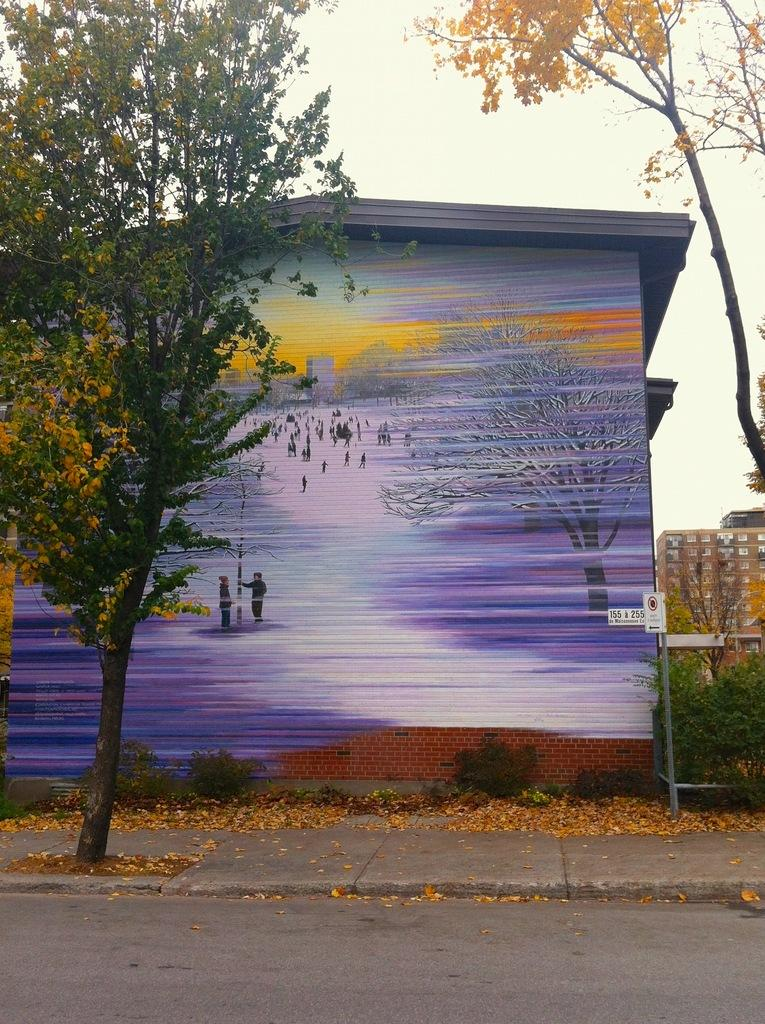What is depicted on the building in the image? There is a picture drawn on the building in the image. What is located in front of the building? There is a tree in front of the building. What can be seen in the right corner of the image? There are trees and another building in the right corner of the image. Where is the pail located in the image? There is no pail present in the image. What type of seat can be seen in the image? There is no seat present in the image. 